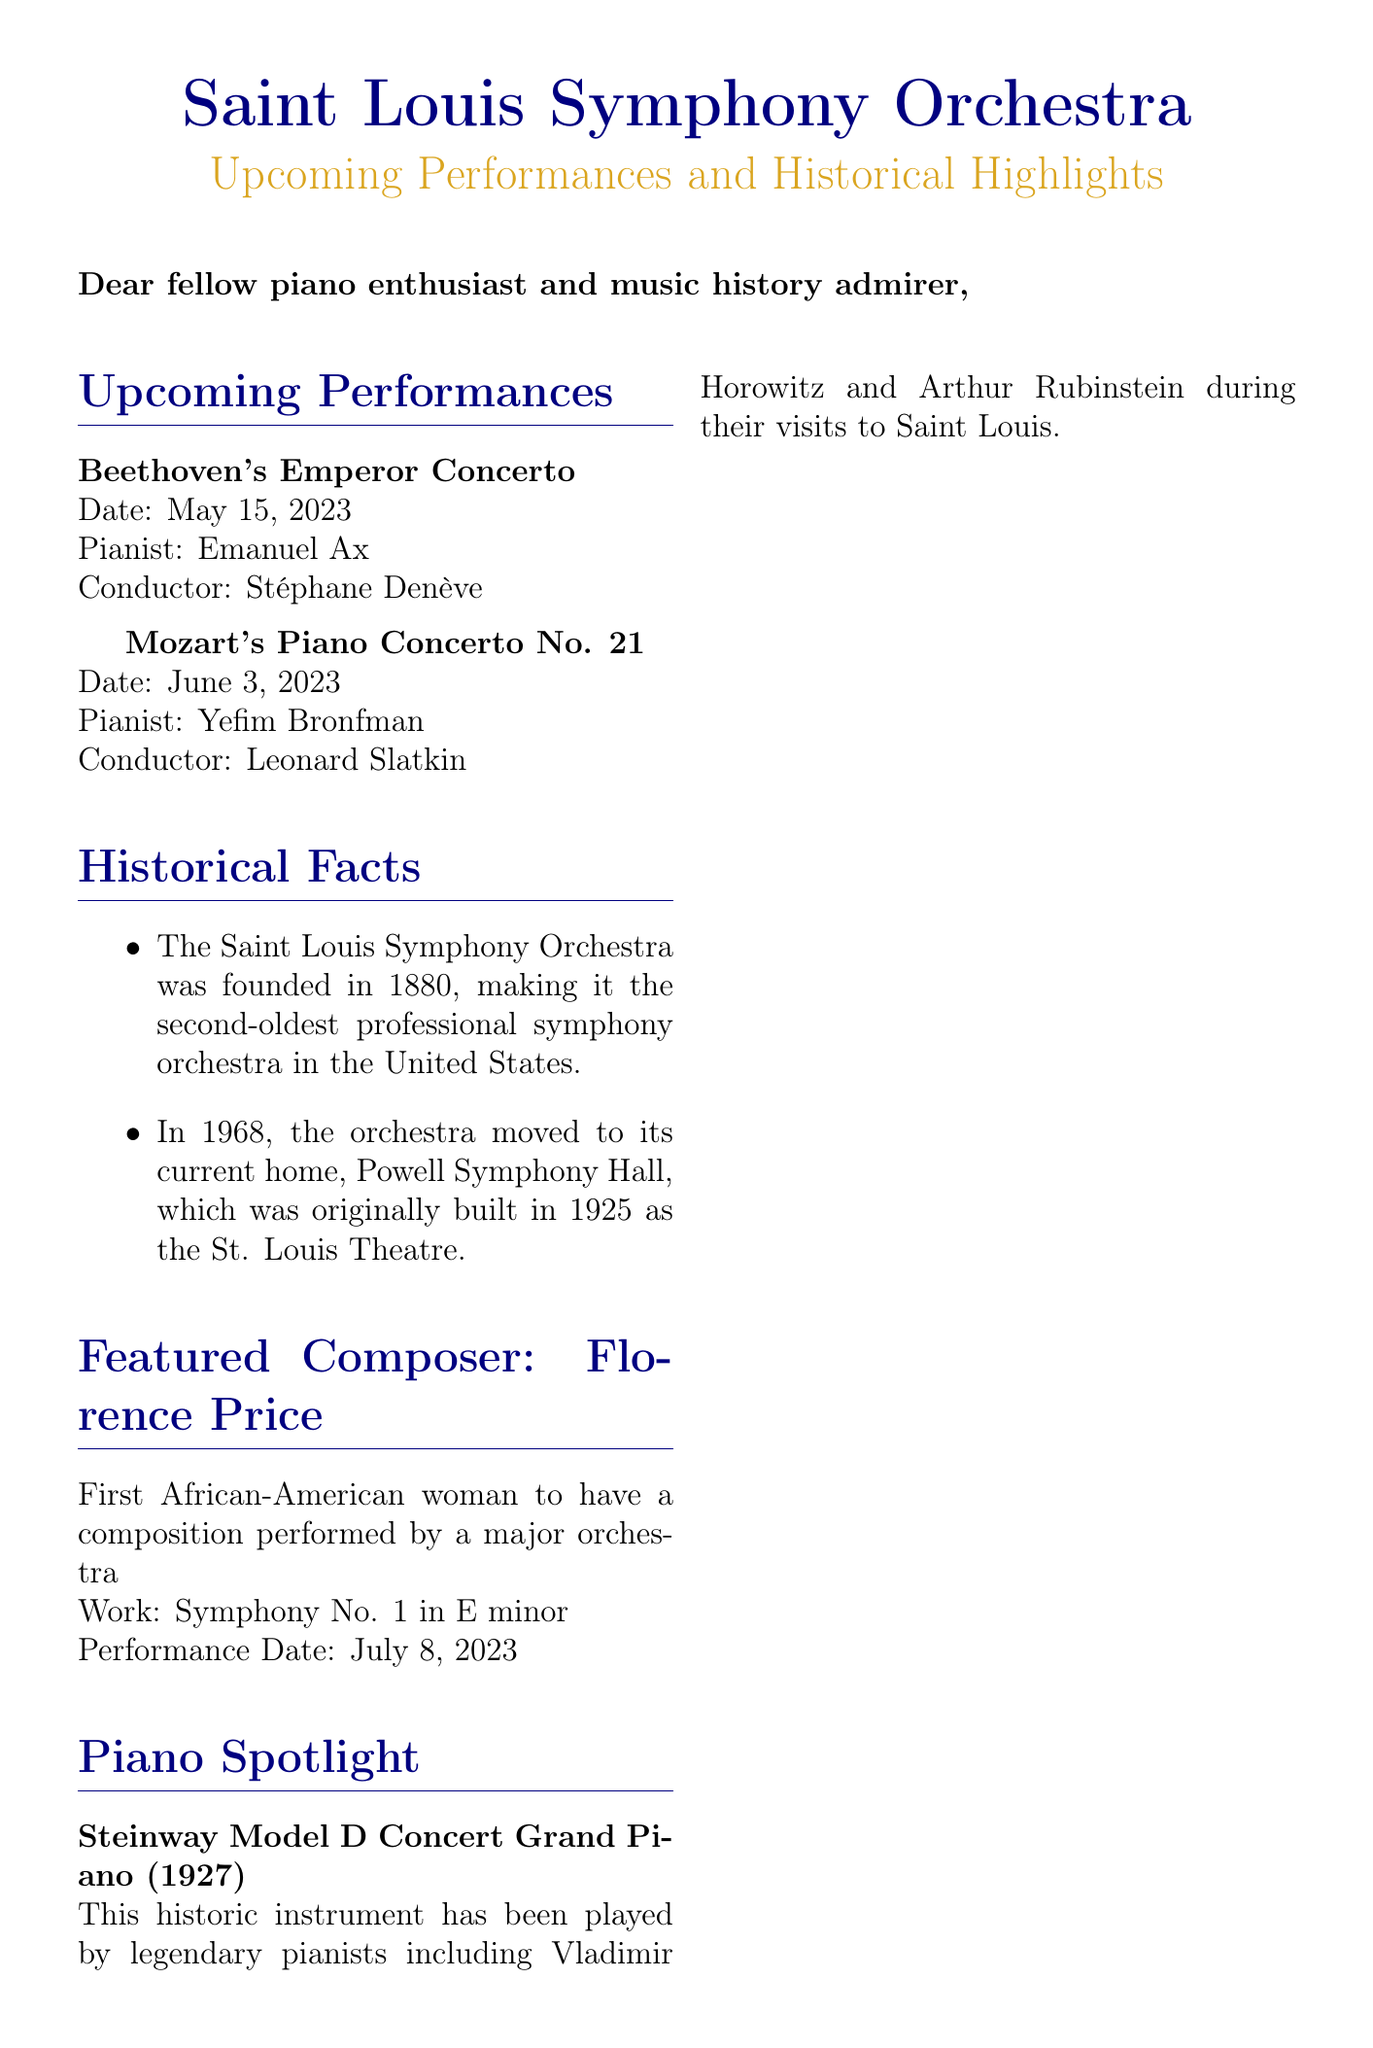What is the date of Beethoven's Emperor Concerto? The date is explicitly stated in the document for this performance.
Answer: May 15, 2023 Who is the featured artist for Mozart's Piano Concerto No. 21? The document lists Yefim Bronfman as the pianist for this performance.
Answer: Yefim Bronfman What year was the Saint Louis Symphony Orchestra founded? This information is provided in the historical facts section of the document.
Answer: 1880 Which piano model is highlighted in the piano spotlight section? The specific model of the piano mentioned is clearly stated in the spotlight section.
Answer: Steinway Model D Concert Grand Piano Who was the composer featured in this newsletter? The newsletter mentions Florence Price as the featured composer along with her significance.
Answer: Florence Price What instrumental work is being performed on July 8, 2023? The document provides the title of the work that Florence Price composed.
Answer: Symphony No. 1 in E minor What is the significance of Powell Symphony Hall according to the document? The document states relevant historical information about Powell Symphony Hall's establishment and purpose.
Answer: Originally built in 1925 as the St. Louis Theatre Who conducted Beethoven's Emperor Concerto? The conductor for this performance is stated directly in the upcoming performances section.
Answer: Stéphane Denève 